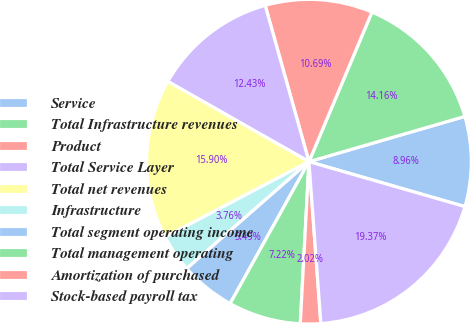<chart> <loc_0><loc_0><loc_500><loc_500><pie_chart><fcel>Service<fcel>Total Infrastructure revenues<fcel>Product<fcel>Total Service Layer<fcel>Total net revenues<fcel>Infrastructure<fcel>Total segment operating income<fcel>Total management operating<fcel>Amortization of purchased<fcel>Stock-based payroll tax<nl><fcel>8.96%<fcel>14.16%<fcel>10.69%<fcel>12.43%<fcel>15.9%<fcel>3.76%<fcel>5.49%<fcel>7.22%<fcel>2.02%<fcel>19.37%<nl></chart> 